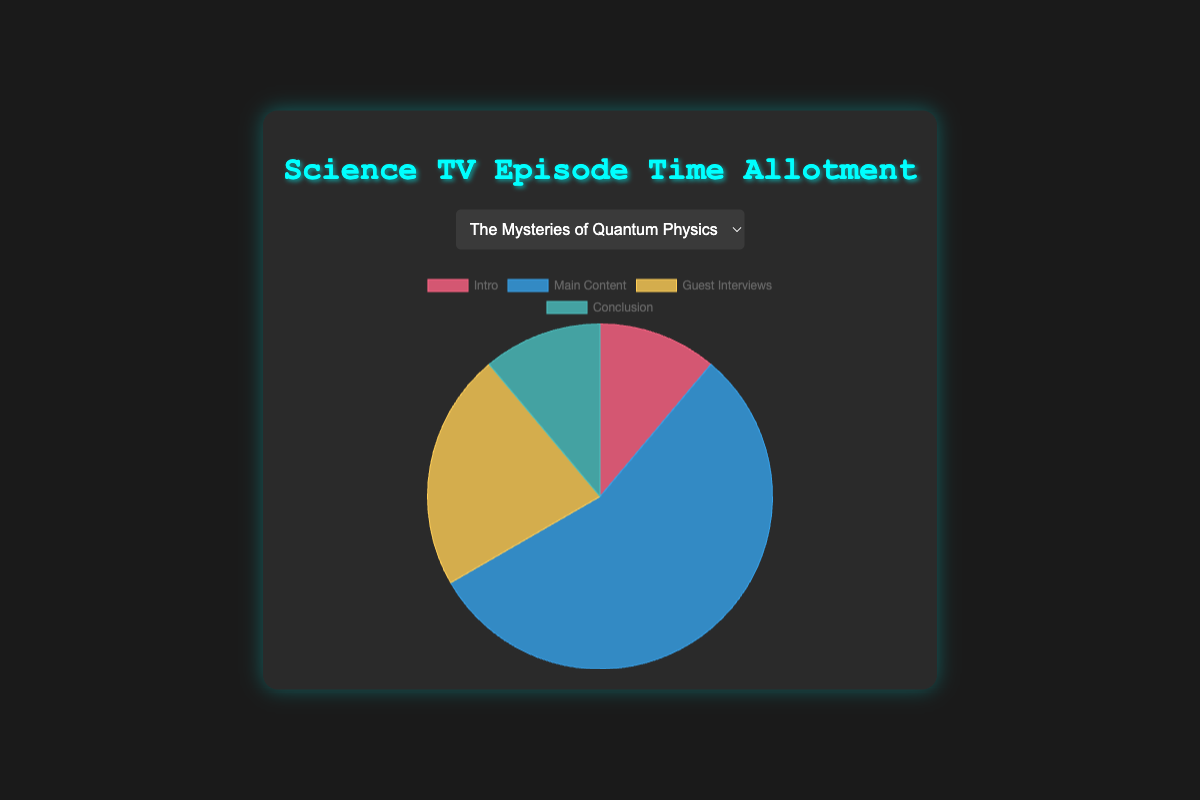What percentage of the time is allotted to the Main Content in "The Mysteries of Quantum Physics"? The Main Content in "The Mysteries of Quantum Physics" occupies 25 minutes out of a total of 45 minutes (5 + 25 + 10 + 5). The percentage is (25/45) * 100 ≈ 55.6%.
Answer: 55.6% Which episode has the longest time allocated to Guest Interviews? Checking the Guest Interviews time across all episodes: "The Mysteries of Quantum Physics" (10 min), "The Wonders of the Solar System" (6 min), "The Future of Artificial Intelligence" (7 min), and "Evolution and Genetics" (8 min). The episode with the longest Guest Interviews time is "The Mysteries of Quantum Physics".
Answer: The Mysteries of Quantum Physics What is the total time allocated for the Conclusion across all episodes? Summing up the time allocated to the Conclusion: "The Mysteries of Quantum Physics" (5 min), "The Wonders of the Solar System" (6 min), "The Future of Artificial Intelligence" (5 min), and "Evolution and Genetics" (6 min). The total is 5 + 6 + 5 + 6 = 22 minutes.
Answer: 22 minutes Which episode has the shortest Intro time? Checking the Intro time across all episodes: "The Mysteries of Quantum Physics" (5 min), "The Wonders of the Solar System" (4 min), "The Future of Artificial Intelligence" (3 min), and "Evolution and Genetics" (4 min). The episode with the shortest Intro is "The Future of Artificial Intelligence".
Answer: The Future of Artificial Intelligence What is the average time allocated to Main Content across all episodes? Summing the Main Content times: 25 (The Mysteries of Quantum Physics) + 28 (The Wonders of the Solar System) + 30 (The Future of Artificial Intelligence) + 27 (Evolution and Genetics) = 110 minutes. Dividing by the number of episodes (4), the average is 110/4 = 27.5 minutes.
Answer: 27.5 minutes Compare the time allocation for Guest Interviews and Main Content in "The Wonders of the Solar System". Which is greater, and by how many minutes? The time allocated to Guest Interviews in "The Wonders of the Solar System" is 6 minutes, while Main Content is 28 minutes. The Main Content is greater by 28 - 6 = 22 minutes.
Answer: Main Content by 22 minutes What fraction of the total episode time does the Conclusion make up in "Evolution and Genetics"? The Conclusion in "Evolution and Genetics" occupies 6 minutes, with total episode time being 45 minutes (4 + 27 + 8 + 6). The fraction is 6/45, which simplifies to 2/15.
Answer: 2/15 Which episode has the smallest difference in time between the Main Content and Guest Interviews? Calculating the differences: "The Mysteries of Quantum Physics" (25-10=15), "The Wonders of the Solar System" (28-6=22), "The Future of Artificial Intelligence" (30-7=23), "Evolution and Genetics" (27-8=19). The smallest difference is 15 minutes in "The Mysteries of Quantum Physics".
Answer: The Mysteries of Quantum Physics 